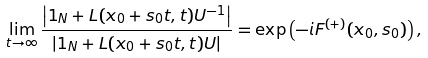Convert formula to latex. <formula><loc_0><loc_0><loc_500><loc_500>\lim _ { t \to \infty } \frac { \left | { 1 } _ { N } + L ( x _ { 0 } + s _ { 0 } t , t ) U ^ { - 1 } \right | } { \left | { 1 } _ { N } + L ( x _ { 0 } + s _ { 0 } t , t ) U \right | } = \exp \left ( - i F ^ { ( + ) } ( x _ { 0 } , s _ { 0 } ) \right ) ,</formula> 